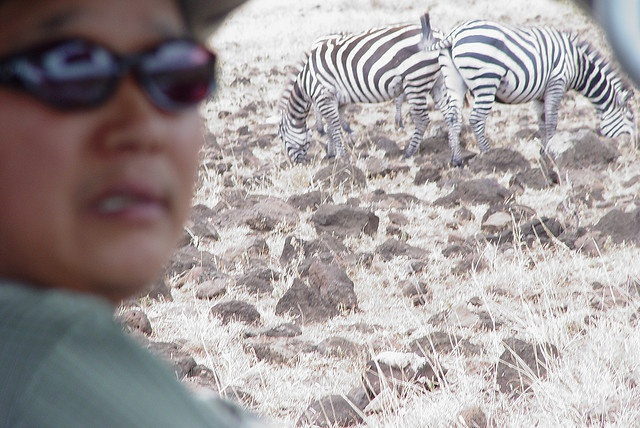Describe the objects in this image and their specific colors. I can see people in brown, gray, maroon, and black tones, zebra in black, lightgray, darkgray, and gray tones, and zebra in black, lightgray, darkgray, and gray tones in this image. 